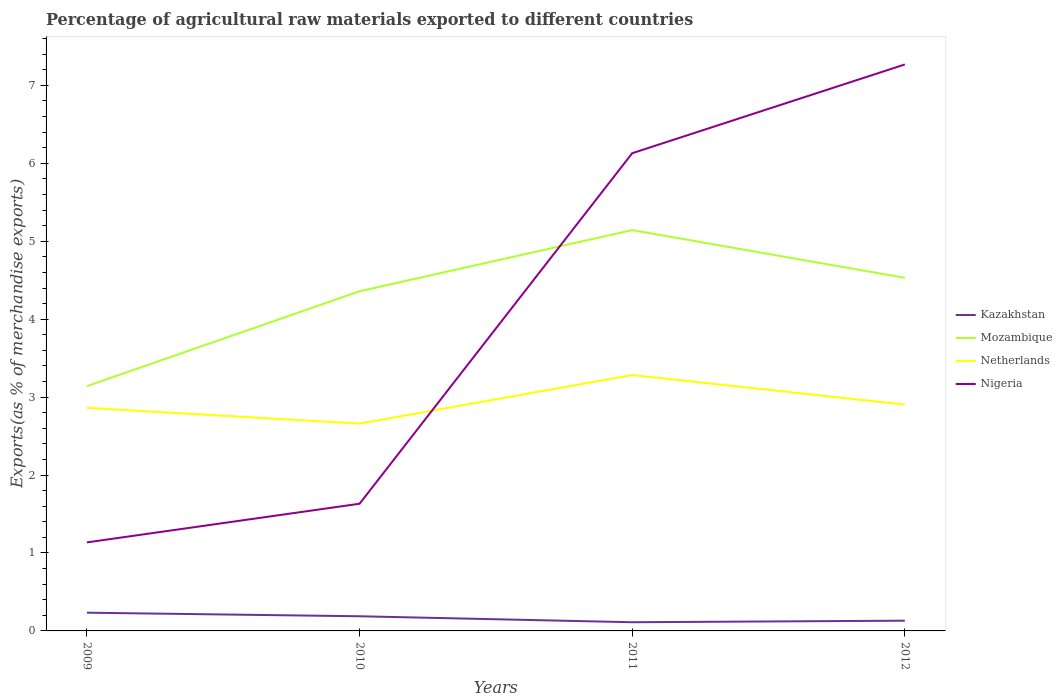Is the number of lines equal to the number of legend labels?
Offer a very short reply. Yes. Across all years, what is the maximum percentage of exports to different countries in Netherlands?
Ensure brevity in your answer.  2.66. In which year was the percentage of exports to different countries in Netherlands maximum?
Offer a very short reply. 2010. What is the total percentage of exports to different countries in Nigeria in the graph?
Ensure brevity in your answer.  -4.99. What is the difference between the highest and the second highest percentage of exports to different countries in Kazakhstan?
Offer a very short reply. 0.12. What is the difference between the highest and the lowest percentage of exports to different countries in Kazakhstan?
Provide a succinct answer. 2. Are the values on the major ticks of Y-axis written in scientific E-notation?
Offer a very short reply. No. Where does the legend appear in the graph?
Offer a very short reply. Center right. How many legend labels are there?
Offer a very short reply. 4. What is the title of the graph?
Provide a short and direct response. Percentage of agricultural raw materials exported to different countries. Does "Sint Maarten (Dutch part)" appear as one of the legend labels in the graph?
Give a very brief answer. No. What is the label or title of the Y-axis?
Your response must be concise. Exports(as % of merchandise exports). What is the Exports(as % of merchandise exports) of Kazakhstan in 2009?
Provide a succinct answer. 0.23. What is the Exports(as % of merchandise exports) of Mozambique in 2009?
Provide a short and direct response. 3.14. What is the Exports(as % of merchandise exports) of Netherlands in 2009?
Ensure brevity in your answer.  2.86. What is the Exports(as % of merchandise exports) in Nigeria in 2009?
Your answer should be very brief. 1.14. What is the Exports(as % of merchandise exports) in Kazakhstan in 2010?
Your answer should be very brief. 0.19. What is the Exports(as % of merchandise exports) in Mozambique in 2010?
Ensure brevity in your answer.  4.36. What is the Exports(as % of merchandise exports) of Netherlands in 2010?
Make the answer very short. 2.66. What is the Exports(as % of merchandise exports) of Nigeria in 2010?
Ensure brevity in your answer.  1.63. What is the Exports(as % of merchandise exports) of Kazakhstan in 2011?
Offer a very short reply. 0.11. What is the Exports(as % of merchandise exports) in Mozambique in 2011?
Your answer should be compact. 5.14. What is the Exports(as % of merchandise exports) of Netherlands in 2011?
Offer a terse response. 3.28. What is the Exports(as % of merchandise exports) in Nigeria in 2011?
Give a very brief answer. 6.13. What is the Exports(as % of merchandise exports) of Kazakhstan in 2012?
Offer a terse response. 0.13. What is the Exports(as % of merchandise exports) of Mozambique in 2012?
Offer a very short reply. 4.53. What is the Exports(as % of merchandise exports) of Netherlands in 2012?
Your response must be concise. 2.9. What is the Exports(as % of merchandise exports) of Nigeria in 2012?
Offer a very short reply. 7.27. Across all years, what is the maximum Exports(as % of merchandise exports) of Kazakhstan?
Ensure brevity in your answer.  0.23. Across all years, what is the maximum Exports(as % of merchandise exports) in Mozambique?
Provide a succinct answer. 5.14. Across all years, what is the maximum Exports(as % of merchandise exports) of Netherlands?
Keep it short and to the point. 3.28. Across all years, what is the maximum Exports(as % of merchandise exports) in Nigeria?
Ensure brevity in your answer.  7.27. Across all years, what is the minimum Exports(as % of merchandise exports) in Kazakhstan?
Your response must be concise. 0.11. Across all years, what is the minimum Exports(as % of merchandise exports) in Mozambique?
Offer a very short reply. 3.14. Across all years, what is the minimum Exports(as % of merchandise exports) in Netherlands?
Your response must be concise. 2.66. Across all years, what is the minimum Exports(as % of merchandise exports) of Nigeria?
Provide a succinct answer. 1.14. What is the total Exports(as % of merchandise exports) of Kazakhstan in the graph?
Make the answer very short. 0.66. What is the total Exports(as % of merchandise exports) in Mozambique in the graph?
Your response must be concise. 17.17. What is the total Exports(as % of merchandise exports) of Netherlands in the graph?
Provide a short and direct response. 11.71. What is the total Exports(as % of merchandise exports) in Nigeria in the graph?
Make the answer very short. 16.17. What is the difference between the Exports(as % of merchandise exports) in Kazakhstan in 2009 and that in 2010?
Ensure brevity in your answer.  0.05. What is the difference between the Exports(as % of merchandise exports) in Mozambique in 2009 and that in 2010?
Offer a terse response. -1.22. What is the difference between the Exports(as % of merchandise exports) in Netherlands in 2009 and that in 2010?
Offer a terse response. 0.2. What is the difference between the Exports(as % of merchandise exports) of Nigeria in 2009 and that in 2010?
Your response must be concise. -0.5. What is the difference between the Exports(as % of merchandise exports) of Kazakhstan in 2009 and that in 2011?
Offer a terse response. 0.12. What is the difference between the Exports(as % of merchandise exports) of Mozambique in 2009 and that in 2011?
Ensure brevity in your answer.  -2. What is the difference between the Exports(as % of merchandise exports) in Netherlands in 2009 and that in 2011?
Offer a terse response. -0.42. What is the difference between the Exports(as % of merchandise exports) of Nigeria in 2009 and that in 2011?
Provide a short and direct response. -4.99. What is the difference between the Exports(as % of merchandise exports) in Kazakhstan in 2009 and that in 2012?
Your answer should be very brief. 0.1. What is the difference between the Exports(as % of merchandise exports) of Mozambique in 2009 and that in 2012?
Your answer should be compact. -1.39. What is the difference between the Exports(as % of merchandise exports) of Netherlands in 2009 and that in 2012?
Offer a very short reply. -0.04. What is the difference between the Exports(as % of merchandise exports) of Nigeria in 2009 and that in 2012?
Make the answer very short. -6.13. What is the difference between the Exports(as % of merchandise exports) of Kazakhstan in 2010 and that in 2011?
Your answer should be compact. 0.08. What is the difference between the Exports(as % of merchandise exports) in Mozambique in 2010 and that in 2011?
Make the answer very short. -0.79. What is the difference between the Exports(as % of merchandise exports) in Netherlands in 2010 and that in 2011?
Keep it short and to the point. -0.62. What is the difference between the Exports(as % of merchandise exports) in Nigeria in 2010 and that in 2011?
Your answer should be compact. -4.5. What is the difference between the Exports(as % of merchandise exports) of Kazakhstan in 2010 and that in 2012?
Your response must be concise. 0.06. What is the difference between the Exports(as % of merchandise exports) of Mozambique in 2010 and that in 2012?
Make the answer very short. -0.17. What is the difference between the Exports(as % of merchandise exports) of Netherlands in 2010 and that in 2012?
Keep it short and to the point. -0.24. What is the difference between the Exports(as % of merchandise exports) of Nigeria in 2010 and that in 2012?
Provide a short and direct response. -5.64. What is the difference between the Exports(as % of merchandise exports) in Kazakhstan in 2011 and that in 2012?
Provide a short and direct response. -0.02. What is the difference between the Exports(as % of merchandise exports) in Mozambique in 2011 and that in 2012?
Ensure brevity in your answer.  0.61. What is the difference between the Exports(as % of merchandise exports) in Netherlands in 2011 and that in 2012?
Your answer should be compact. 0.38. What is the difference between the Exports(as % of merchandise exports) of Nigeria in 2011 and that in 2012?
Provide a succinct answer. -1.14. What is the difference between the Exports(as % of merchandise exports) of Kazakhstan in 2009 and the Exports(as % of merchandise exports) of Mozambique in 2010?
Give a very brief answer. -4.12. What is the difference between the Exports(as % of merchandise exports) in Kazakhstan in 2009 and the Exports(as % of merchandise exports) in Netherlands in 2010?
Ensure brevity in your answer.  -2.43. What is the difference between the Exports(as % of merchandise exports) of Kazakhstan in 2009 and the Exports(as % of merchandise exports) of Nigeria in 2010?
Provide a short and direct response. -1.4. What is the difference between the Exports(as % of merchandise exports) of Mozambique in 2009 and the Exports(as % of merchandise exports) of Netherlands in 2010?
Your response must be concise. 0.48. What is the difference between the Exports(as % of merchandise exports) in Mozambique in 2009 and the Exports(as % of merchandise exports) in Nigeria in 2010?
Give a very brief answer. 1.51. What is the difference between the Exports(as % of merchandise exports) in Netherlands in 2009 and the Exports(as % of merchandise exports) in Nigeria in 2010?
Offer a terse response. 1.23. What is the difference between the Exports(as % of merchandise exports) in Kazakhstan in 2009 and the Exports(as % of merchandise exports) in Mozambique in 2011?
Make the answer very short. -4.91. What is the difference between the Exports(as % of merchandise exports) in Kazakhstan in 2009 and the Exports(as % of merchandise exports) in Netherlands in 2011?
Provide a short and direct response. -3.05. What is the difference between the Exports(as % of merchandise exports) in Kazakhstan in 2009 and the Exports(as % of merchandise exports) in Nigeria in 2011?
Your answer should be very brief. -5.9. What is the difference between the Exports(as % of merchandise exports) of Mozambique in 2009 and the Exports(as % of merchandise exports) of Netherlands in 2011?
Offer a terse response. -0.14. What is the difference between the Exports(as % of merchandise exports) of Mozambique in 2009 and the Exports(as % of merchandise exports) of Nigeria in 2011?
Your answer should be compact. -2.99. What is the difference between the Exports(as % of merchandise exports) in Netherlands in 2009 and the Exports(as % of merchandise exports) in Nigeria in 2011?
Offer a very short reply. -3.27. What is the difference between the Exports(as % of merchandise exports) of Kazakhstan in 2009 and the Exports(as % of merchandise exports) of Mozambique in 2012?
Provide a succinct answer. -4.3. What is the difference between the Exports(as % of merchandise exports) of Kazakhstan in 2009 and the Exports(as % of merchandise exports) of Netherlands in 2012?
Provide a short and direct response. -2.67. What is the difference between the Exports(as % of merchandise exports) in Kazakhstan in 2009 and the Exports(as % of merchandise exports) in Nigeria in 2012?
Give a very brief answer. -7.03. What is the difference between the Exports(as % of merchandise exports) of Mozambique in 2009 and the Exports(as % of merchandise exports) of Netherlands in 2012?
Ensure brevity in your answer.  0.24. What is the difference between the Exports(as % of merchandise exports) of Mozambique in 2009 and the Exports(as % of merchandise exports) of Nigeria in 2012?
Your answer should be very brief. -4.13. What is the difference between the Exports(as % of merchandise exports) in Netherlands in 2009 and the Exports(as % of merchandise exports) in Nigeria in 2012?
Provide a succinct answer. -4.41. What is the difference between the Exports(as % of merchandise exports) in Kazakhstan in 2010 and the Exports(as % of merchandise exports) in Mozambique in 2011?
Ensure brevity in your answer.  -4.96. What is the difference between the Exports(as % of merchandise exports) in Kazakhstan in 2010 and the Exports(as % of merchandise exports) in Netherlands in 2011?
Give a very brief answer. -3.1. What is the difference between the Exports(as % of merchandise exports) in Kazakhstan in 2010 and the Exports(as % of merchandise exports) in Nigeria in 2011?
Your response must be concise. -5.94. What is the difference between the Exports(as % of merchandise exports) in Mozambique in 2010 and the Exports(as % of merchandise exports) in Netherlands in 2011?
Provide a succinct answer. 1.07. What is the difference between the Exports(as % of merchandise exports) of Mozambique in 2010 and the Exports(as % of merchandise exports) of Nigeria in 2011?
Your answer should be very brief. -1.77. What is the difference between the Exports(as % of merchandise exports) in Netherlands in 2010 and the Exports(as % of merchandise exports) in Nigeria in 2011?
Your response must be concise. -3.47. What is the difference between the Exports(as % of merchandise exports) of Kazakhstan in 2010 and the Exports(as % of merchandise exports) of Mozambique in 2012?
Your answer should be compact. -4.34. What is the difference between the Exports(as % of merchandise exports) of Kazakhstan in 2010 and the Exports(as % of merchandise exports) of Netherlands in 2012?
Your answer should be compact. -2.72. What is the difference between the Exports(as % of merchandise exports) of Kazakhstan in 2010 and the Exports(as % of merchandise exports) of Nigeria in 2012?
Provide a succinct answer. -7.08. What is the difference between the Exports(as % of merchandise exports) in Mozambique in 2010 and the Exports(as % of merchandise exports) in Netherlands in 2012?
Offer a terse response. 1.45. What is the difference between the Exports(as % of merchandise exports) in Mozambique in 2010 and the Exports(as % of merchandise exports) in Nigeria in 2012?
Your answer should be compact. -2.91. What is the difference between the Exports(as % of merchandise exports) of Netherlands in 2010 and the Exports(as % of merchandise exports) of Nigeria in 2012?
Ensure brevity in your answer.  -4.61. What is the difference between the Exports(as % of merchandise exports) in Kazakhstan in 2011 and the Exports(as % of merchandise exports) in Mozambique in 2012?
Give a very brief answer. -4.42. What is the difference between the Exports(as % of merchandise exports) of Kazakhstan in 2011 and the Exports(as % of merchandise exports) of Netherlands in 2012?
Offer a terse response. -2.79. What is the difference between the Exports(as % of merchandise exports) in Kazakhstan in 2011 and the Exports(as % of merchandise exports) in Nigeria in 2012?
Your answer should be compact. -7.16. What is the difference between the Exports(as % of merchandise exports) in Mozambique in 2011 and the Exports(as % of merchandise exports) in Netherlands in 2012?
Provide a succinct answer. 2.24. What is the difference between the Exports(as % of merchandise exports) in Mozambique in 2011 and the Exports(as % of merchandise exports) in Nigeria in 2012?
Offer a very short reply. -2.13. What is the difference between the Exports(as % of merchandise exports) in Netherlands in 2011 and the Exports(as % of merchandise exports) in Nigeria in 2012?
Give a very brief answer. -3.98. What is the average Exports(as % of merchandise exports) of Kazakhstan per year?
Your response must be concise. 0.17. What is the average Exports(as % of merchandise exports) in Mozambique per year?
Provide a succinct answer. 4.29. What is the average Exports(as % of merchandise exports) of Netherlands per year?
Your answer should be compact. 2.93. What is the average Exports(as % of merchandise exports) in Nigeria per year?
Ensure brevity in your answer.  4.04. In the year 2009, what is the difference between the Exports(as % of merchandise exports) of Kazakhstan and Exports(as % of merchandise exports) of Mozambique?
Your response must be concise. -2.91. In the year 2009, what is the difference between the Exports(as % of merchandise exports) in Kazakhstan and Exports(as % of merchandise exports) in Netherlands?
Your response must be concise. -2.63. In the year 2009, what is the difference between the Exports(as % of merchandise exports) in Kazakhstan and Exports(as % of merchandise exports) in Nigeria?
Provide a succinct answer. -0.9. In the year 2009, what is the difference between the Exports(as % of merchandise exports) in Mozambique and Exports(as % of merchandise exports) in Netherlands?
Keep it short and to the point. 0.28. In the year 2009, what is the difference between the Exports(as % of merchandise exports) in Mozambique and Exports(as % of merchandise exports) in Nigeria?
Your answer should be compact. 2. In the year 2009, what is the difference between the Exports(as % of merchandise exports) of Netherlands and Exports(as % of merchandise exports) of Nigeria?
Offer a terse response. 1.73. In the year 2010, what is the difference between the Exports(as % of merchandise exports) of Kazakhstan and Exports(as % of merchandise exports) of Mozambique?
Offer a very short reply. -4.17. In the year 2010, what is the difference between the Exports(as % of merchandise exports) in Kazakhstan and Exports(as % of merchandise exports) in Netherlands?
Keep it short and to the point. -2.47. In the year 2010, what is the difference between the Exports(as % of merchandise exports) in Kazakhstan and Exports(as % of merchandise exports) in Nigeria?
Offer a terse response. -1.44. In the year 2010, what is the difference between the Exports(as % of merchandise exports) in Mozambique and Exports(as % of merchandise exports) in Netherlands?
Keep it short and to the point. 1.7. In the year 2010, what is the difference between the Exports(as % of merchandise exports) in Mozambique and Exports(as % of merchandise exports) in Nigeria?
Provide a short and direct response. 2.73. In the year 2010, what is the difference between the Exports(as % of merchandise exports) of Netherlands and Exports(as % of merchandise exports) of Nigeria?
Make the answer very short. 1.03. In the year 2011, what is the difference between the Exports(as % of merchandise exports) of Kazakhstan and Exports(as % of merchandise exports) of Mozambique?
Offer a terse response. -5.03. In the year 2011, what is the difference between the Exports(as % of merchandise exports) of Kazakhstan and Exports(as % of merchandise exports) of Netherlands?
Keep it short and to the point. -3.17. In the year 2011, what is the difference between the Exports(as % of merchandise exports) of Kazakhstan and Exports(as % of merchandise exports) of Nigeria?
Your answer should be compact. -6.02. In the year 2011, what is the difference between the Exports(as % of merchandise exports) of Mozambique and Exports(as % of merchandise exports) of Netherlands?
Ensure brevity in your answer.  1.86. In the year 2011, what is the difference between the Exports(as % of merchandise exports) of Mozambique and Exports(as % of merchandise exports) of Nigeria?
Your response must be concise. -0.99. In the year 2011, what is the difference between the Exports(as % of merchandise exports) of Netherlands and Exports(as % of merchandise exports) of Nigeria?
Give a very brief answer. -2.85. In the year 2012, what is the difference between the Exports(as % of merchandise exports) in Kazakhstan and Exports(as % of merchandise exports) in Mozambique?
Your answer should be very brief. -4.4. In the year 2012, what is the difference between the Exports(as % of merchandise exports) of Kazakhstan and Exports(as % of merchandise exports) of Netherlands?
Ensure brevity in your answer.  -2.77. In the year 2012, what is the difference between the Exports(as % of merchandise exports) of Kazakhstan and Exports(as % of merchandise exports) of Nigeria?
Offer a very short reply. -7.14. In the year 2012, what is the difference between the Exports(as % of merchandise exports) in Mozambique and Exports(as % of merchandise exports) in Netherlands?
Provide a succinct answer. 1.63. In the year 2012, what is the difference between the Exports(as % of merchandise exports) in Mozambique and Exports(as % of merchandise exports) in Nigeria?
Provide a succinct answer. -2.74. In the year 2012, what is the difference between the Exports(as % of merchandise exports) in Netherlands and Exports(as % of merchandise exports) in Nigeria?
Your response must be concise. -4.36. What is the ratio of the Exports(as % of merchandise exports) in Kazakhstan in 2009 to that in 2010?
Your response must be concise. 1.24. What is the ratio of the Exports(as % of merchandise exports) in Mozambique in 2009 to that in 2010?
Your answer should be compact. 0.72. What is the ratio of the Exports(as % of merchandise exports) in Netherlands in 2009 to that in 2010?
Provide a short and direct response. 1.08. What is the ratio of the Exports(as % of merchandise exports) of Nigeria in 2009 to that in 2010?
Offer a terse response. 0.7. What is the ratio of the Exports(as % of merchandise exports) of Kazakhstan in 2009 to that in 2011?
Your answer should be compact. 2.1. What is the ratio of the Exports(as % of merchandise exports) in Mozambique in 2009 to that in 2011?
Offer a very short reply. 0.61. What is the ratio of the Exports(as % of merchandise exports) of Netherlands in 2009 to that in 2011?
Provide a short and direct response. 0.87. What is the ratio of the Exports(as % of merchandise exports) of Nigeria in 2009 to that in 2011?
Offer a very short reply. 0.19. What is the ratio of the Exports(as % of merchandise exports) in Kazakhstan in 2009 to that in 2012?
Your answer should be compact. 1.78. What is the ratio of the Exports(as % of merchandise exports) of Mozambique in 2009 to that in 2012?
Make the answer very short. 0.69. What is the ratio of the Exports(as % of merchandise exports) in Netherlands in 2009 to that in 2012?
Your answer should be compact. 0.99. What is the ratio of the Exports(as % of merchandise exports) of Nigeria in 2009 to that in 2012?
Your answer should be very brief. 0.16. What is the ratio of the Exports(as % of merchandise exports) in Kazakhstan in 2010 to that in 2011?
Offer a very short reply. 1.69. What is the ratio of the Exports(as % of merchandise exports) in Mozambique in 2010 to that in 2011?
Your response must be concise. 0.85. What is the ratio of the Exports(as % of merchandise exports) in Netherlands in 2010 to that in 2011?
Keep it short and to the point. 0.81. What is the ratio of the Exports(as % of merchandise exports) in Nigeria in 2010 to that in 2011?
Your answer should be compact. 0.27. What is the ratio of the Exports(as % of merchandise exports) in Kazakhstan in 2010 to that in 2012?
Offer a very short reply. 1.43. What is the ratio of the Exports(as % of merchandise exports) in Mozambique in 2010 to that in 2012?
Provide a short and direct response. 0.96. What is the ratio of the Exports(as % of merchandise exports) of Netherlands in 2010 to that in 2012?
Your answer should be very brief. 0.92. What is the ratio of the Exports(as % of merchandise exports) in Nigeria in 2010 to that in 2012?
Offer a terse response. 0.22. What is the ratio of the Exports(as % of merchandise exports) in Kazakhstan in 2011 to that in 2012?
Provide a short and direct response. 0.85. What is the ratio of the Exports(as % of merchandise exports) of Mozambique in 2011 to that in 2012?
Provide a short and direct response. 1.14. What is the ratio of the Exports(as % of merchandise exports) in Netherlands in 2011 to that in 2012?
Keep it short and to the point. 1.13. What is the ratio of the Exports(as % of merchandise exports) in Nigeria in 2011 to that in 2012?
Offer a very short reply. 0.84. What is the difference between the highest and the second highest Exports(as % of merchandise exports) in Kazakhstan?
Give a very brief answer. 0.05. What is the difference between the highest and the second highest Exports(as % of merchandise exports) of Mozambique?
Provide a succinct answer. 0.61. What is the difference between the highest and the second highest Exports(as % of merchandise exports) of Netherlands?
Ensure brevity in your answer.  0.38. What is the difference between the highest and the second highest Exports(as % of merchandise exports) of Nigeria?
Your answer should be compact. 1.14. What is the difference between the highest and the lowest Exports(as % of merchandise exports) in Kazakhstan?
Offer a terse response. 0.12. What is the difference between the highest and the lowest Exports(as % of merchandise exports) of Mozambique?
Your response must be concise. 2. What is the difference between the highest and the lowest Exports(as % of merchandise exports) in Netherlands?
Offer a terse response. 0.62. What is the difference between the highest and the lowest Exports(as % of merchandise exports) of Nigeria?
Your response must be concise. 6.13. 